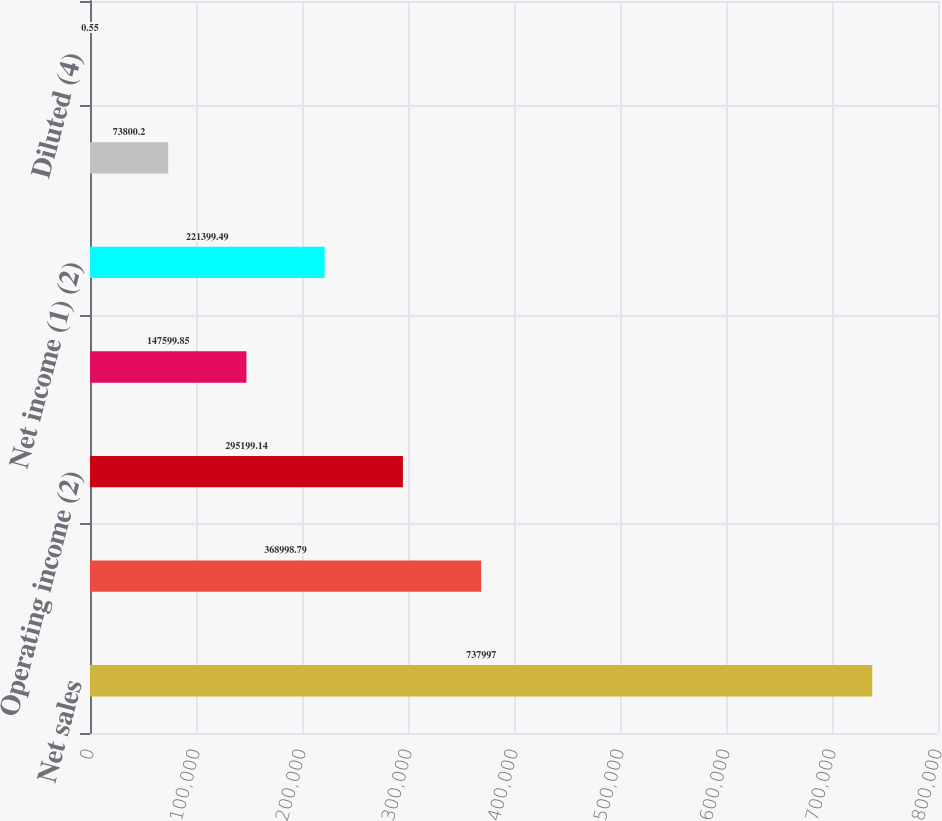<chart> <loc_0><loc_0><loc_500><loc_500><bar_chart><fcel>Net sales<fcel>Gross profit<fcel>Operating income (2)<fcel>Net income from continuing<fcel>Net income (1) (2)<fcel>Basic<fcel>Diluted (4)<nl><fcel>737997<fcel>368999<fcel>295199<fcel>147600<fcel>221399<fcel>73800.2<fcel>0.55<nl></chart> 